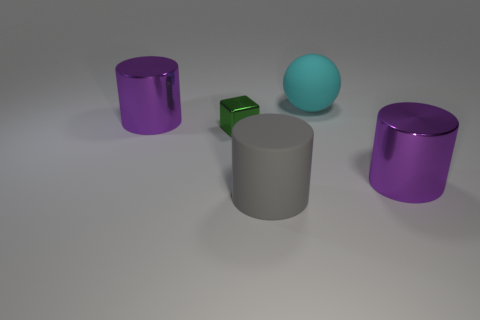Do the thing to the right of the large cyan matte sphere and the big cyan object have the same shape?
Your answer should be compact. No. What is the shape of the green metallic thing?
Keep it short and to the point. Cube. What is the purple thing that is in front of the big purple thing that is to the left of the matte thing left of the cyan rubber thing made of?
Make the answer very short. Metal. How many objects are big cyan things or gray rubber things?
Make the answer very short. 2. Do the purple cylinder right of the cube and the cyan sphere have the same material?
Your answer should be compact. No. How many things are big metal things that are right of the big cyan rubber object or big matte things?
Your answer should be compact. 3. There is another large thing that is made of the same material as the gray object; what color is it?
Provide a short and direct response. Cyan. Is there a ball that has the same size as the cyan rubber thing?
Offer a very short reply. No. Do the large object right of the cyan matte object and the small metallic thing have the same color?
Keep it short and to the point. No. There is a large cylinder that is behind the large gray matte cylinder and to the right of the small block; what is its color?
Your response must be concise. Purple. 